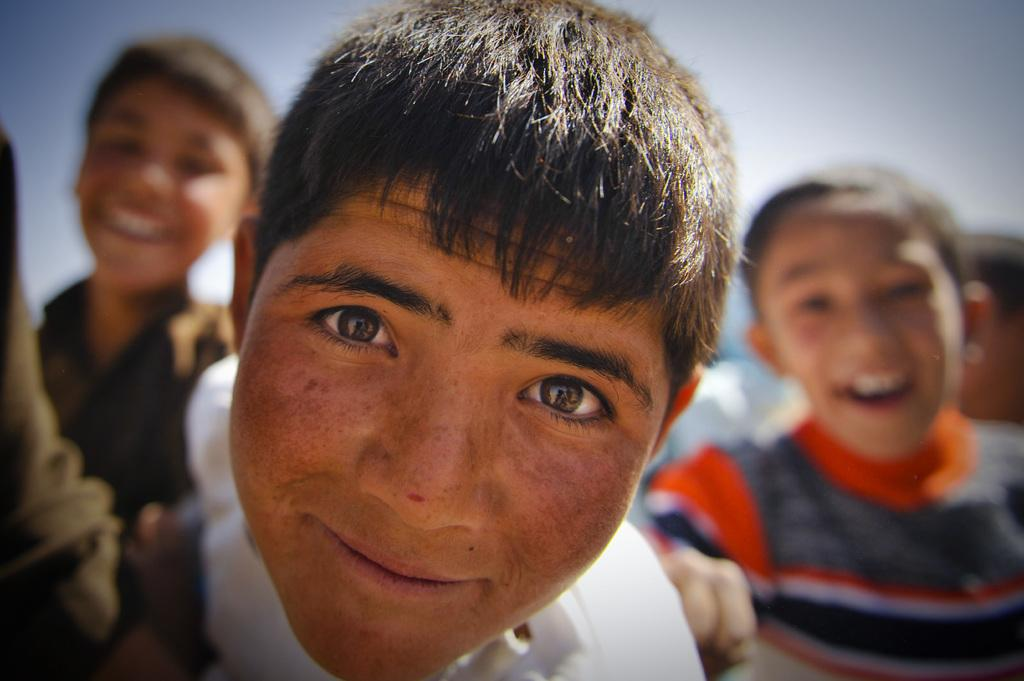What is the main subject of the image? There is a person's face in the center of the image. What can be seen in the background of the image? There is sky visible in the background of the image. Are there any other people in the image? Yes, there are other persons in the background of the image. What type of plastic object can be seen in the person's hand in the image? There is no plastic object visible in the person's hand in the image. What word is written on the person's forehead in the image? There are no words written on the person's forehead in the image. 